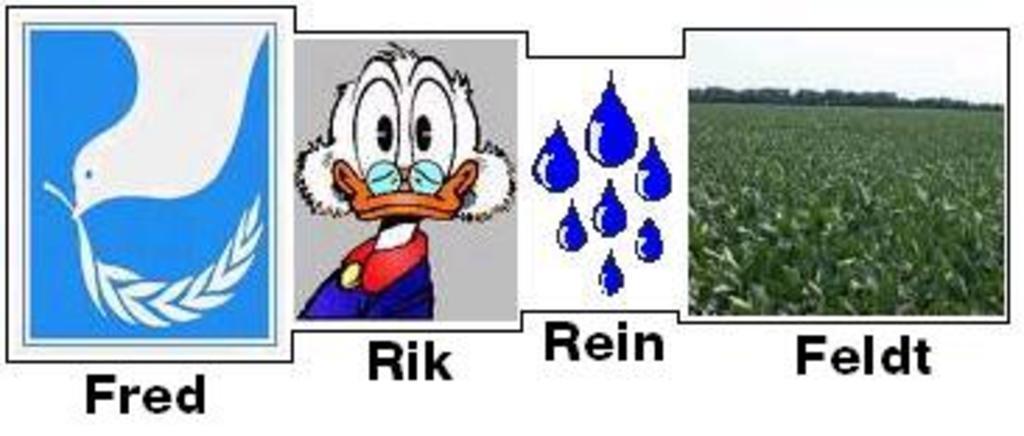Can you describe this image briefly? In this image I can see animated pictures of a bird, donald and raindrops. On the right I can see a farm and the sky. This image is taken may be during a day. 